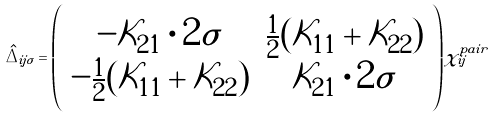Convert formula to latex. <formula><loc_0><loc_0><loc_500><loc_500>\hat { \Delta } _ { i j \sigma } = \left ( \begin{array} { c c } - \mathcal { K } _ { 2 1 } \cdot 2 \sigma & \frac { 1 } { 2 } ( \mathcal { K } _ { 1 1 } + \mathcal { K } _ { 2 2 } ) \\ - \frac { 1 } { 2 } ( \mathcal { K } _ { 1 1 } + \mathcal { K } _ { 2 2 } ) & \mathcal { K } _ { 2 1 } \cdot 2 \sigma \end{array} \right ) \chi _ { i j } ^ { p a i r }</formula> 